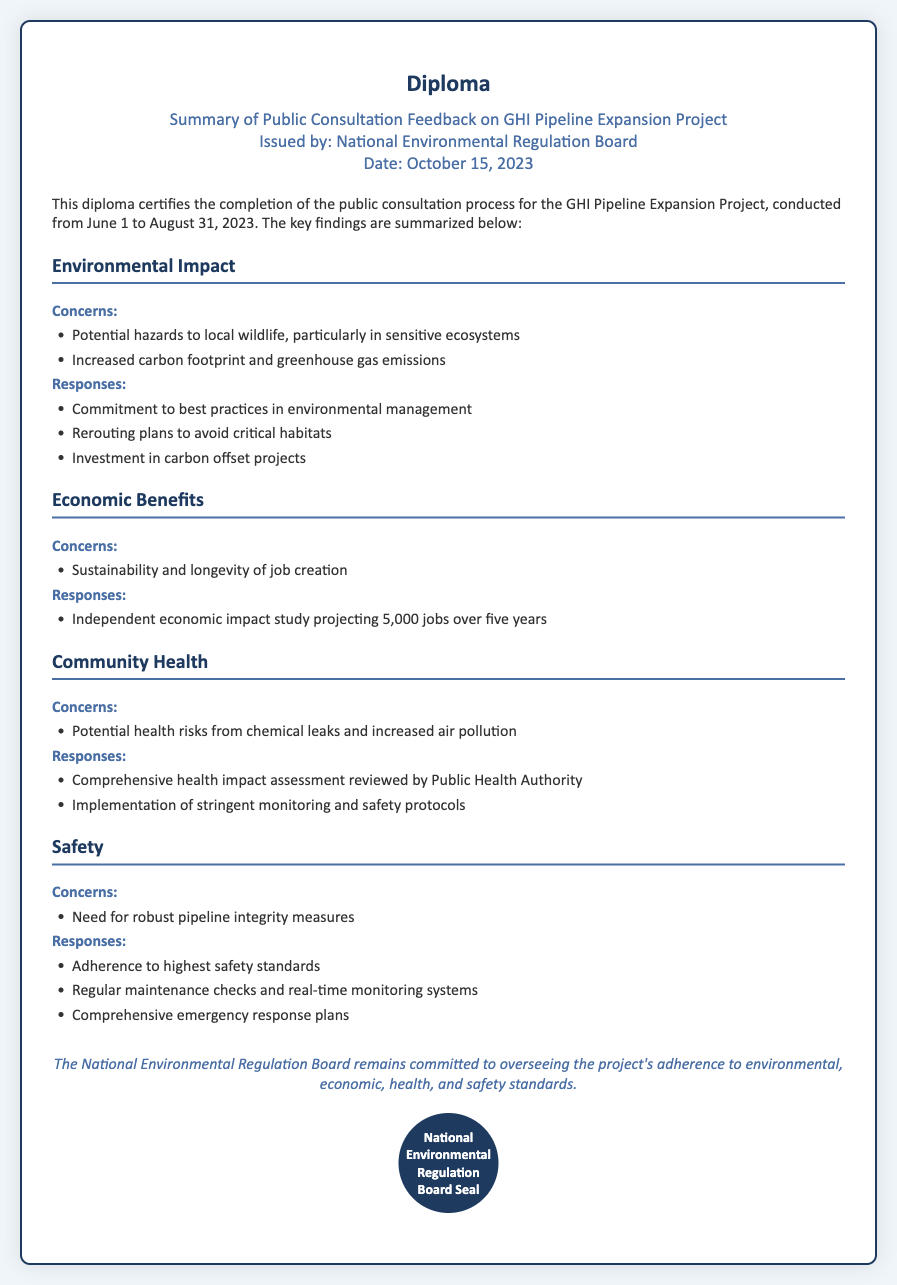what is the title of the document? The title is prominently displayed at the top of the document, indicating the main focus.
Answer: Summary of Public Consultation Feedback on GHI Pipeline Expansion Project who issued the document? The issuing body is stated clearly in the sub-header section of the document.
Answer: National Environmental Regulation Board when was the public consultation conducted? The document specifies the duration of the consultation process within the introductory paragraph.
Answer: June 1 to August 31, 2023 how many jobs are projected from the economic impact study? The document includes information about job projections in the economic benefits section, providing a specific number.
Answer: 5,000 what are the concerns regarding community health? The document lists specific community health concerns under the relevant section, providing a focused view of public sentiments.
Answer: Potential health risks from chemical leaks and increased air pollution what is one of the responses to safety concerns? The document under the safety section outlines responses to concerns, including various measures for safety.
Answer: Adherence to highest safety standards how does the document characterize its commitment? The closing statement of the document emphasizes the regulatory body's dedication and focus.
Answer: Committed to overseeing the project's adherence to environmental, economic, health, and safety standards 